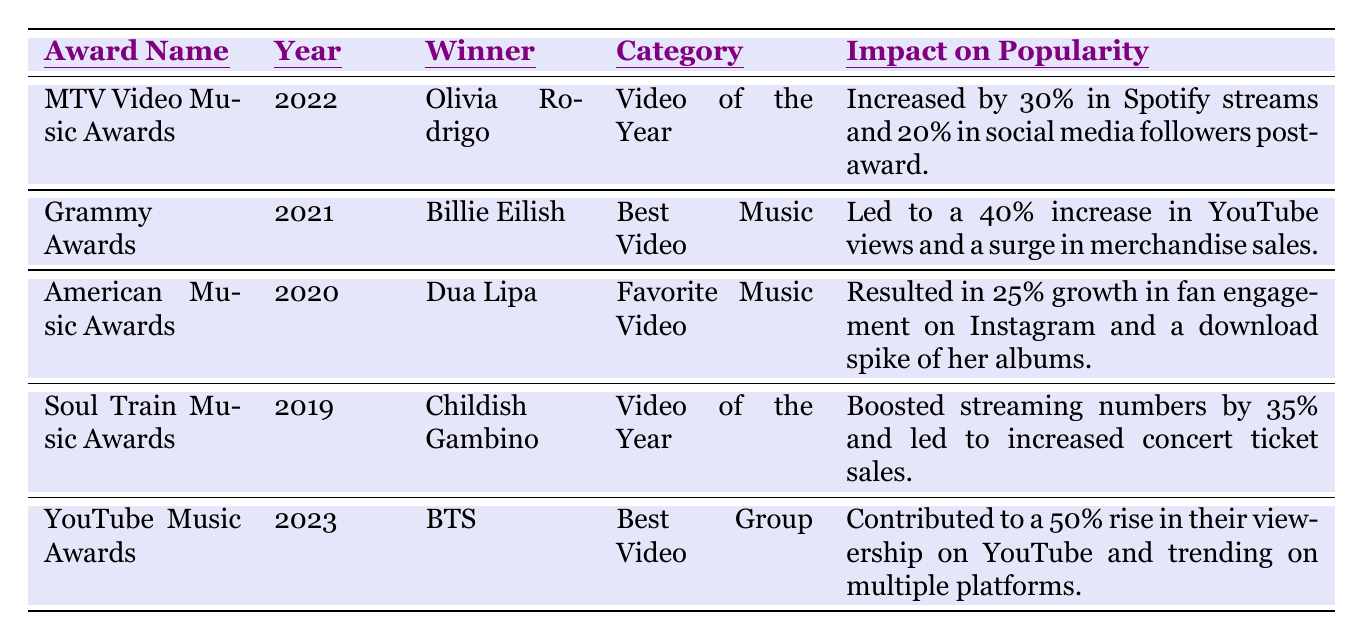What artist won the MTV Video Music Award in 2022? The table indicates that Olivia Rodrigo won the MTV Video Music Award in 2022 in the category of Video of the Year.
Answer: Olivia Rodrigo How much did BTS's popularity increase after winning the YouTube Music Award in 2023? According to the table, BTS's popularity increased by 50% in terms of viewership on YouTube after winning the award.
Answer: 50% Which award did Billie Eilish win and in what year? The table shows that Billie Eilish won the Grammy Award in 2021 in the category of Best Music Video.
Answer: Grammy Award in 2021 Was there any increase in fan engagement for Dua Lipa after winning the American Music Award in 2020? Yes, the table states that Dua Lipa had a 25% growth in fan engagement on Instagram after winning the award.
Answer: Yes What is the total percentage increase in streaming numbers for both Childish Gambino and Olivia Rodrigo after their respective awards? Childish Gambino's streaming numbers increased by 35% and Olivia Rodrigo's by 30%. Summing these gives 35 + 30 = 65%.
Answer: 65% Which winner had the highest impact on popularity according to the table, and how significant was it? The table indicates that BTS had the highest impact with a 50% rise in their viewership on YouTube after winning an award.
Answer: BTS with 50% Did any of the artists' awards lead to increased merchandise sales? Yes, the table states that after Billie Eilish won the Grammy Award, there was a surge in merchandise sales.
Answer: Yes What was the percentage increase in social media followers for Olivia Rodrigo post-award? After winning the MTV Video Music Award, Olivia Rodrigo's social media followers increased by 20%.
Answer: 20% If we consider all winners, what was the median impact on popularity? To find the median, we first list the impacts: 30%, 40%, 25%, 35%, and 50%. Arranging them gives 25%, 30%, 35%, 40%, 50%. The median is the middle value, which is 35%.
Answer: 35% How many different categories were represented in the table? The categories listed are Video of the Year, Best Music Video, Favorite Music Video, and Best Group Video, which totals four distinct categories.
Answer: 4 